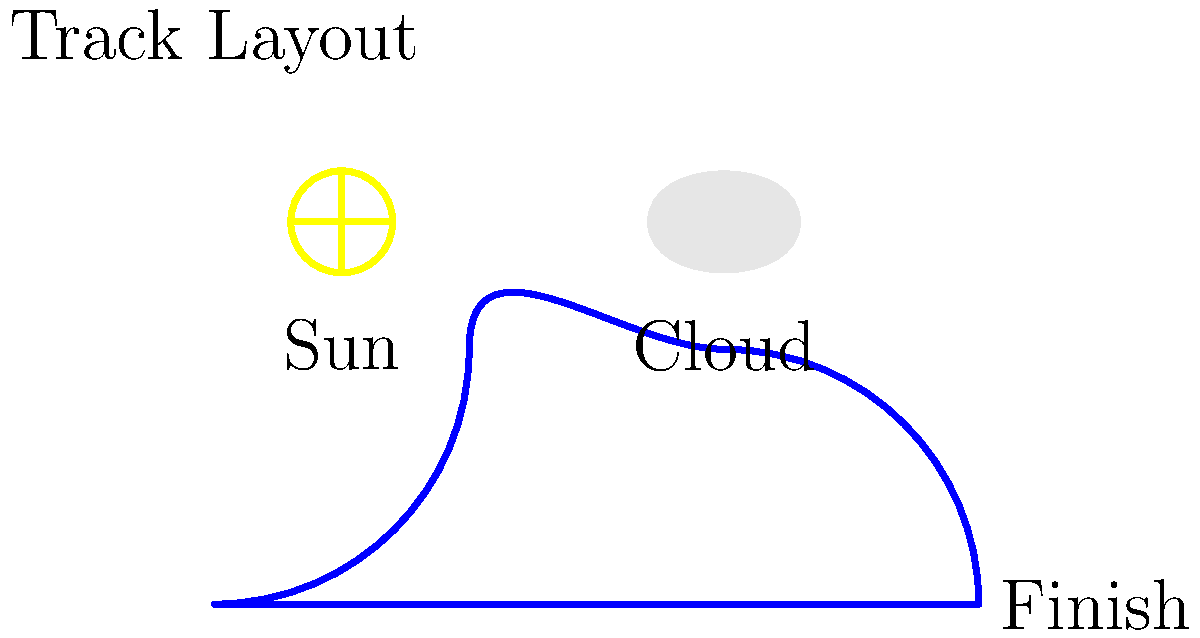As a BMX cyclist, you're preparing for an upcoming race. Given the track layout and weather conditions shown in the diagram, which machine learning model would be most suitable for predicting your finish time, and what key features should be considered? To predict race finish times based on track layouts and weather conditions, we need to consider several factors and choose an appropriate machine learning model. Here's a step-by-step approach:

1. Identify key features:
   a) Track characteristics: length, number of turns, elevation changes
   b) Weather conditions: temperature, humidity, wind speed, precipitation
   c) Rider statistics: weight, height, experience level, recent performance

2. Data collection:
   Gather historical data on race times, track layouts, and weather conditions from previous events.

3. Feature engineering:
   Create numerical representations for track layout (e.g., turn sharpness, straight section lengths) and weather conditions (e.g., sunny = 1, cloudy = 0.5).

4. Model selection:
   For this type of prediction, a Random Forest Regression model would be suitable because:
   a) It can handle both numerical and categorical features
   b) It can capture non-linear relationships between features and finish times
   c) It's less prone to overfitting compared to single decision trees
   d) It can provide feature importance, helping identify which factors most influence finish times

5. Model training:
   Split the historical data into training and testing sets, then train the Random Forest model on the training data.

6. Model evaluation:
   Use metrics like Mean Absolute Error (MAE) or Root Mean Squared Error (RMSE) to assess the model's performance on the test set.

7. Feature importance analysis:
   Examine which features have the most significant impact on predicted finish times.

8. Fine-tuning:
   Adjust hyperparameters (e.g., number of trees, max depth) to optimize model performance.

9. Deployment:
   Use the trained model to predict finish times for new track layouts and weather conditions.

Key features to consider:
- Track length
- Number and sharpness of turns
- Elevation changes
- Weather conditions (temperature, humidity, wind speed)
- Rider's past performance on similar tracks
Answer: Random Forest Regression model with track layout, weather conditions, and rider statistics as key features. 